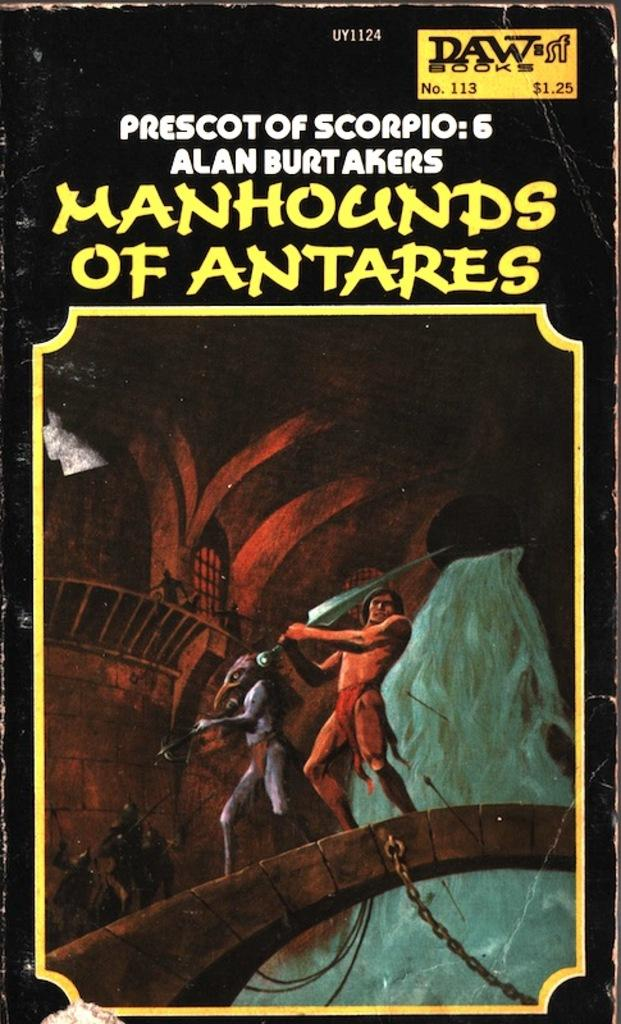<image>
Create a compact narrative representing the image presented. A book with the title Manhounds of Antares. 